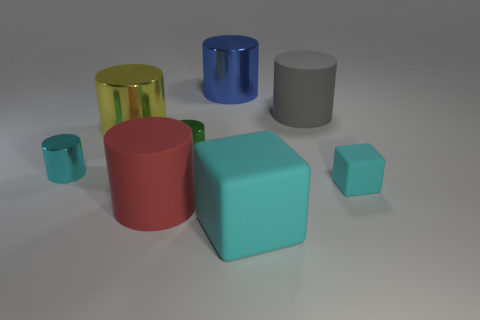There is a small rubber object; does it have the same color as the large rubber object that is in front of the big red thing?
Keep it short and to the point. Yes. There is a cube on the left side of the small cyan cube; does it have the same color as the tiny matte cube?
Ensure brevity in your answer.  Yes. What number of other objects are there of the same color as the tiny rubber cube?
Offer a terse response. 2. Do the tiny cube and the large rubber cube have the same color?
Your response must be concise. Yes. What is the size of the cylinder that is the same color as the small block?
Give a very brief answer. Small. Are there any small metallic objects that have the same color as the small matte cube?
Your answer should be very brief. Yes. There is a rubber object to the right of the big gray matte object; is its color the same as the metallic object in front of the green thing?
Provide a short and direct response. Yes. What number of other objects are the same size as the yellow cylinder?
Ensure brevity in your answer.  4. What is the color of the big matte cube?
Make the answer very short. Cyan. What material is the block that is in front of the large red cylinder?
Offer a very short reply. Rubber. 